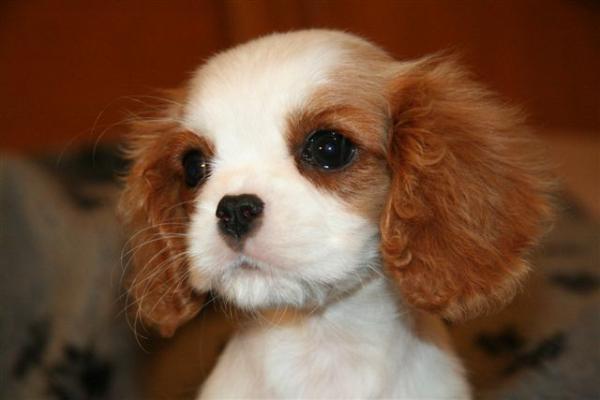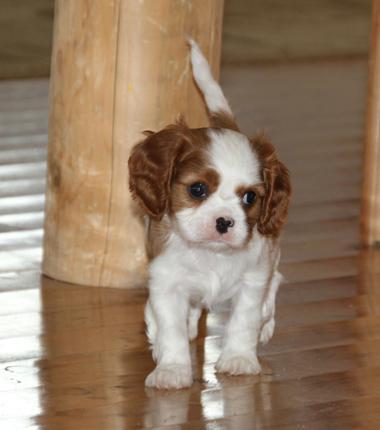The first image is the image on the left, the second image is the image on the right. Considering the images on both sides, is "Ine one of the images only the dog's head is visible" valid? Answer yes or no. Yes. The first image is the image on the left, the second image is the image on the right. Evaluate the accuracy of this statement regarding the images: "An image shows a brown and white puppy on a shiny wood floor.". Is it true? Answer yes or no. Yes. 